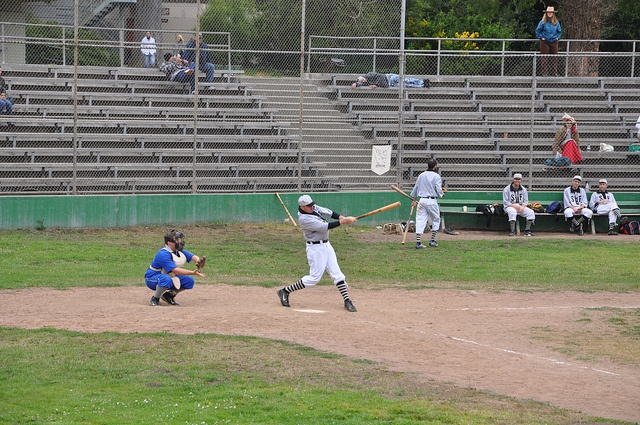Describe the objects in this image and their specific colors. I can see people in black, lavender, darkgray, and gray tones, people in black, gray, blue, and darkblue tones, people in black, lavender, darkgray, and gray tones, bench in black, darkgray, teal, and gray tones, and people in black, lavender, gray, and darkgray tones in this image. 